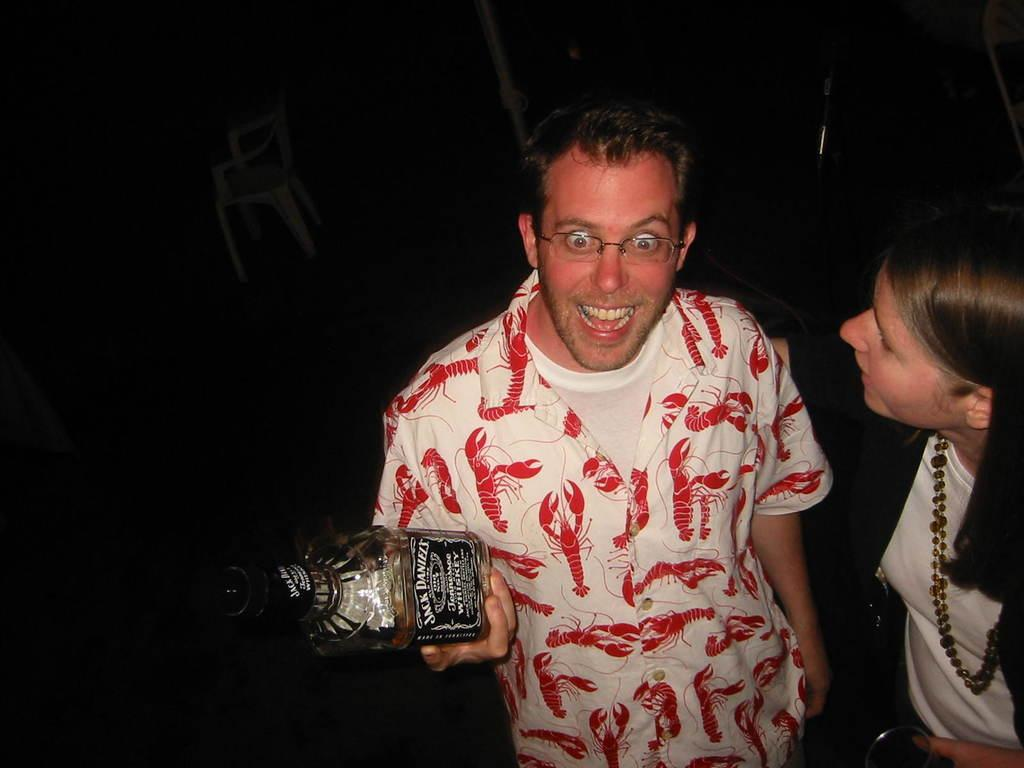What is the person in the image holding? The person is holding a bottle in the image. Can you describe the other person in the image? There is another person truncated towards the right in the image. What type of furniture is present in the image? There is a chair in the image. What is the color of the background in the image? The background of the image is dark. How many spiders are crawling on the sidewalk in the image? There are no spiders or sidewalks present in the image. What type of transport is visible in the image? There is no transport visible in the image. 